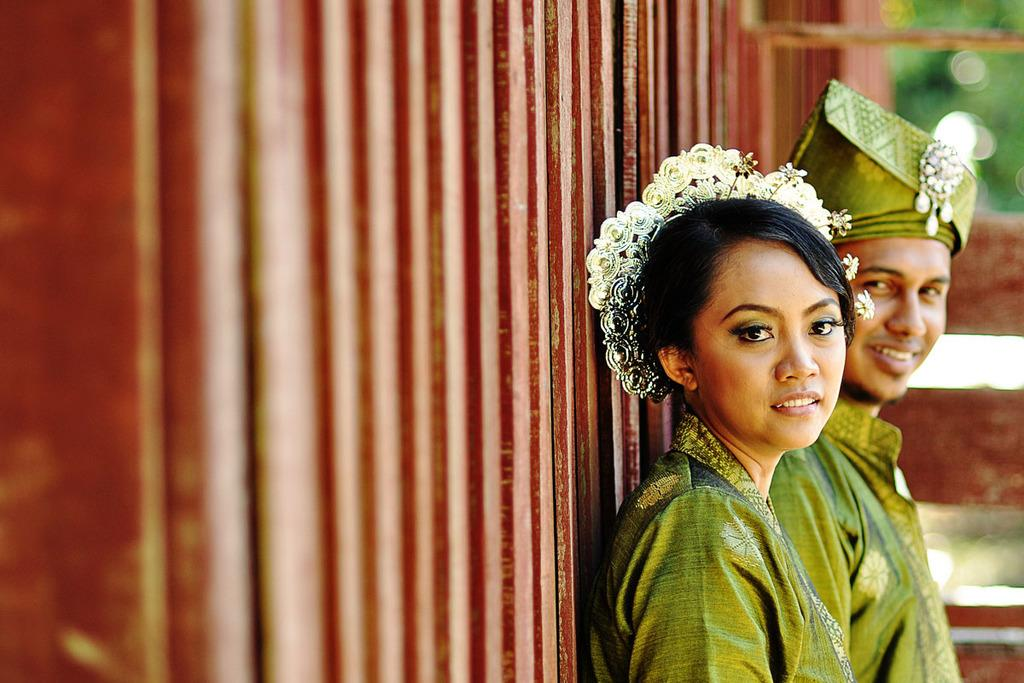How many people are in the image? There are two persons in the image. What are the people wearing? Both persons are wearing green-colored dresses. Can you describe any additional accessories worn by one of the persons? One of the persons is wearing a green-colored thing on their head. What type of berry can be seen growing on the plane in the image? There is no plane or berry present in the image; it features two persons wearing green-colored dresses. 